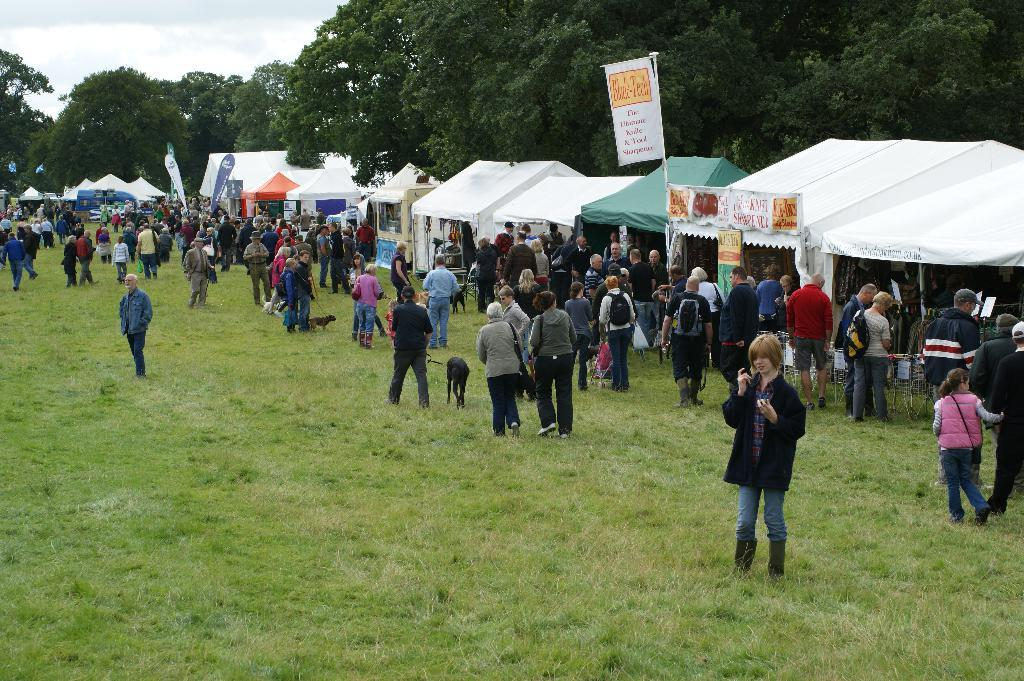What are the people in the image doing? The people in the image are walking on the grass. What structure can be seen in the image? There is a tent in the image. What type of vegetation is present in the image? There are trees in the image. What type of winter clothing can be seen on the secretary in the image? There is no secretary or winter clothing present in the image. Can you tell me how many donkeys are grazing near the tent in the image? There are no donkeys present in the image; it features people walking on the grass and a tent. 